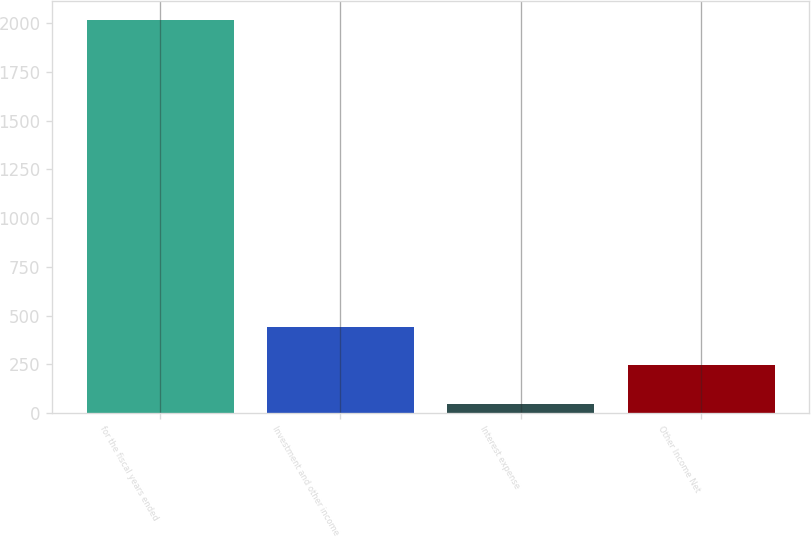Convert chart to OTSL. <chart><loc_0><loc_0><loc_500><loc_500><bar_chart><fcel>for the fiscal years ended<fcel>Investment and other income<fcel>Interest expense<fcel>Other Income Net<nl><fcel>2014<fcel>440.72<fcel>47.4<fcel>244.06<nl></chart> 